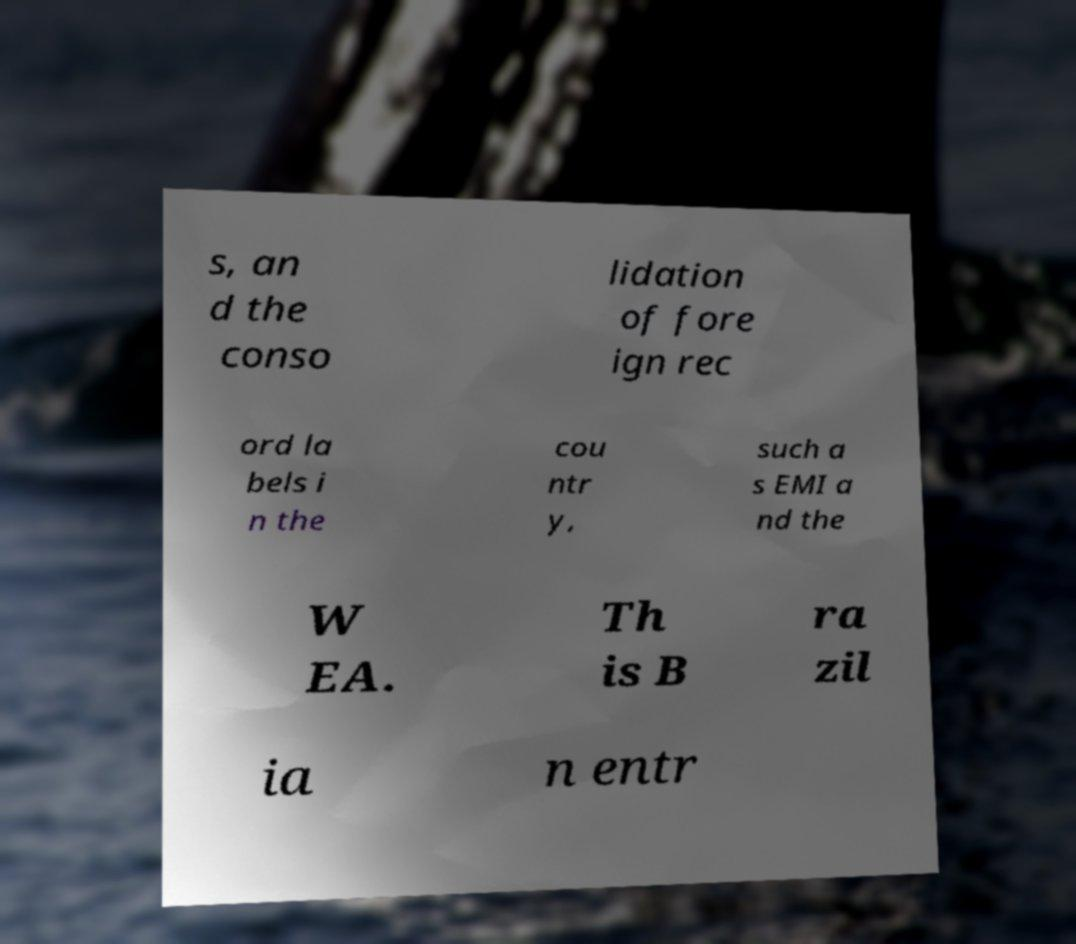Could you extract and type out the text from this image? s, an d the conso lidation of fore ign rec ord la bels i n the cou ntr y, such a s EMI a nd the W EA. Th is B ra zil ia n entr 